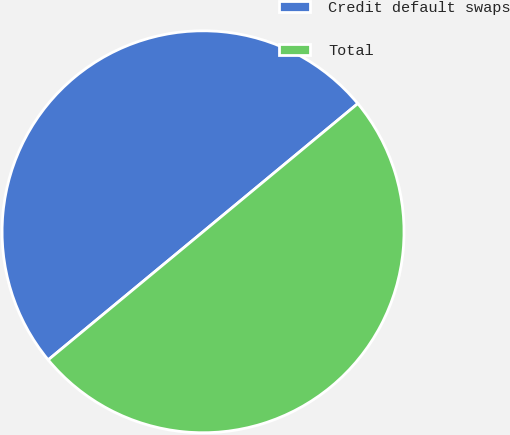<chart> <loc_0><loc_0><loc_500><loc_500><pie_chart><fcel>Credit default swaps<fcel>Total<nl><fcel>49.99%<fcel>50.01%<nl></chart> 